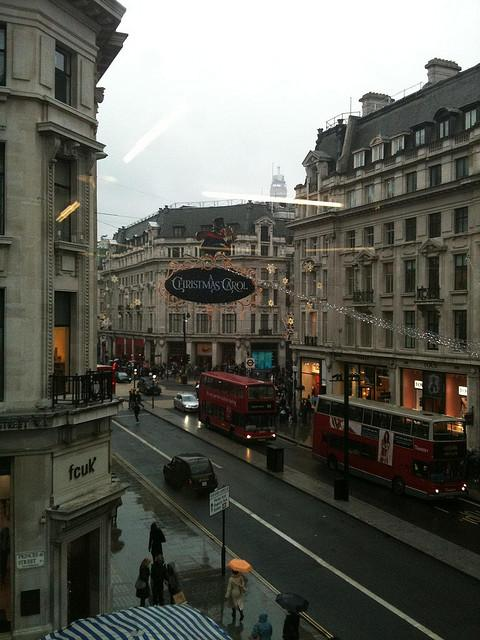Why is the woman carrying an orange umbrella? raining 